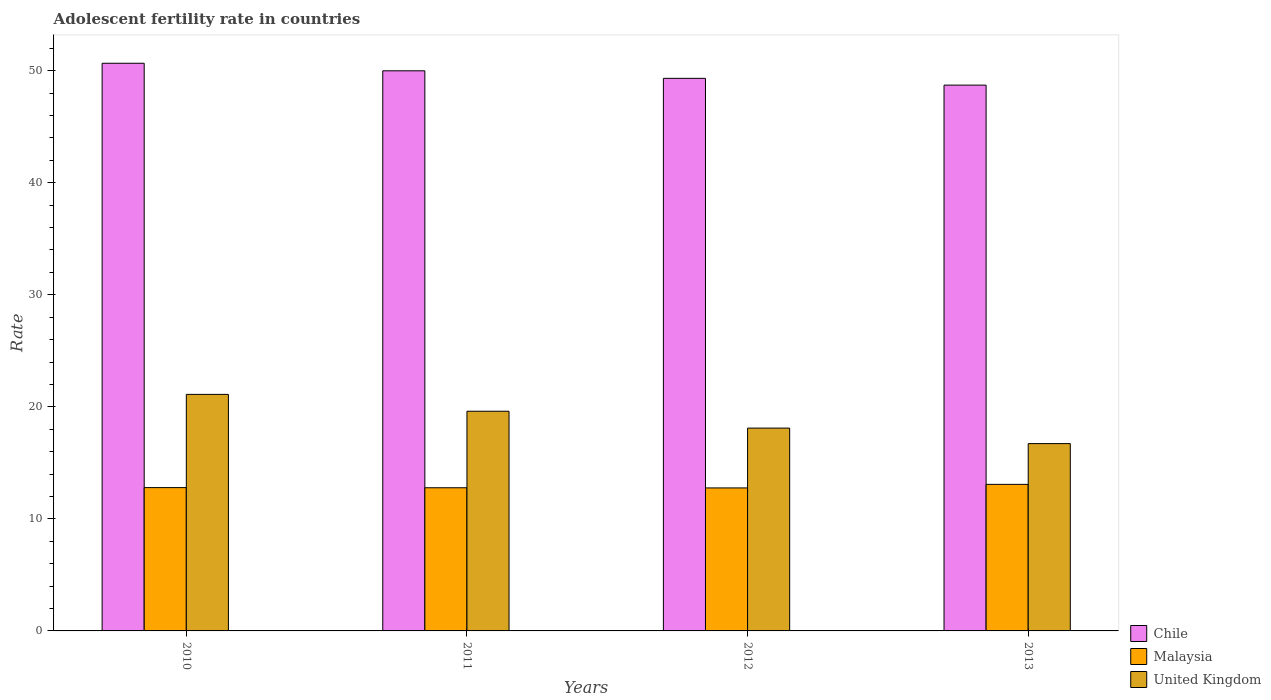How many different coloured bars are there?
Offer a terse response. 3. Are the number of bars per tick equal to the number of legend labels?
Provide a short and direct response. Yes. Are the number of bars on each tick of the X-axis equal?
Your answer should be compact. Yes. In how many cases, is the number of bars for a given year not equal to the number of legend labels?
Provide a short and direct response. 0. What is the adolescent fertility rate in United Kingdom in 2013?
Offer a terse response. 16.72. Across all years, what is the maximum adolescent fertility rate in Chile?
Your response must be concise. 50.67. Across all years, what is the minimum adolescent fertility rate in United Kingdom?
Offer a very short reply. 16.72. What is the total adolescent fertility rate in Chile in the graph?
Offer a very short reply. 198.69. What is the difference between the adolescent fertility rate in Malaysia in 2011 and that in 2012?
Provide a succinct answer. 0.02. What is the difference between the adolescent fertility rate in United Kingdom in 2011 and the adolescent fertility rate in Chile in 2012?
Provide a succinct answer. -29.71. What is the average adolescent fertility rate in Chile per year?
Your answer should be very brief. 49.67. In the year 2010, what is the difference between the adolescent fertility rate in Malaysia and adolescent fertility rate in Chile?
Offer a very short reply. -37.87. What is the ratio of the adolescent fertility rate in Malaysia in 2010 to that in 2012?
Provide a succinct answer. 1. Is the adolescent fertility rate in Chile in 2010 less than that in 2011?
Offer a very short reply. No. What is the difference between the highest and the second highest adolescent fertility rate in Malaysia?
Give a very brief answer. 0.29. What is the difference between the highest and the lowest adolescent fertility rate in Chile?
Give a very brief answer. 1.95. Is the sum of the adolescent fertility rate in Malaysia in 2010 and 2012 greater than the maximum adolescent fertility rate in Chile across all years?
Your answer should be very brief. No. What does the 2nd bar from the left in 2012 represents?
Give a very brief answer. Malaysia. What does the 2nd bar from the right in 2010 represents?
Your answer should be very brief. Malaysia. Is it the case that in every year, the sum of the adolescent fertility rate in Malaysia and adolescent fertility rate in Chile is greater than the adolescent fertility rate in United Kingdom?
Make the answer very short. Yes. Are all the bars in the graph horizontal?
Offer a terse response. No. How are the legend labels stacked?
Offer a terse response. Vertical. What is the title of the graph?
Your response must be concise. Adolescent fertility rate in countries. What is the label or title of the X-axis?
Your answer should be very brief. Years. What is the label or title of the Y-axis?
Offer a very short reply. Rate. What is the Rate in Chile in 2010?
Ensure brevity in your answer.  50.67. What is the Rate of Malaysia in 2010?
Keep it short and to the point. 12.79. What is the Rate in United Kingdom in 2010?
Make the answer very short. 21.11. What is the Rate of Chile in 2011?
Keep it short and to the point. 49.99. What is the Rate of Malaysia in 2011?
Keep it short and to the point. 12.78. What is the Rate in United Kingdom in 2011?
Ensure brevity in your answer.  19.61. What is the Rate in Chile in 2012?
Your answer should be compact. 49.32. What is the Rate in Malaysia in 2012?
Your answer should be compact. 12.76. What is the Rate of United Kingdom in 2012?
Your answer should be compact. 18.1. What is the Rate of Chile in 2013?
Your answer should be very brief. 48.71. What is the Rate of Malaysia in 2013?
Provide a short and direct response. 13.08. What is the Rate of United Kingdom in 2013?
Ensure brevity in your answer.  16.72. Across all years, what is the maximum Rate of Chile?
Your answer should be very brief. 50.67. Across all years, what is the maximum Rate in Malaysia?
Keep it short and to the point. 13.08. Across all years, what is the maximum Rate of United Kingdom?
Provide a succinct answer. 21.11. Across all years, what is the minimum Rate in Chile?
Your response must be concise. 48.71. Across all years, what is the minimum Rate of Malaysia?
Make the answer very short. 12.76. Across all years, what is the minimum Rate in United Kingdom?
Offer a terse response. 16.72. What is the total Rate of Chile in the graph?
Provide a succinct answer. 198.69. What is the total Rate in Malaysia in the graph?
Your response must be concise. 51.41. What is the total Rate of United Kingdom in the graph?
Your response must be concise. 75.54. What is the difference between the Rate of Chile in 2010 and that in 2011?
Ensure brevity in your answer.  0.67. What is the difference between the Rate of Malaysia in 2010 and that in 2011?
Keep it short and to the point. 0.02. What is the difference between the Rate in United Kingdom in 2010 and that in 2011?
Your answer should be very brief. 1.5. What is the difference between the Rate in Chile in 2010 and that in 2012?
Give a very brief answer. 1.35. What is the difference between the Rate in Malaysia in 2010 and that in 2012?
Your answer should be compact. 0.03. What is the difference between the Rate in United Kingdom in 2010 and that in 2012?
Your answer should be compact. 3.01. What is the difference between the Rate of Chile in 2010 and that in 2013?
Offer a very short reply. 1.95. What is the difference between the Rate of Malaysia in 2010 and that in 2013?
Keep it short and to the point. -0.29. What is the difference between the Rate of United Kingdom in 2010 and that in 2013?
Provide a short and direct response. 4.39. What is the difference between the Rate of Chile in 2011 and that in 2012?
Keep it short and to the point. 0.67. What is the difference between the Rate in Malaysia in 2011 and that in 2012?
Provide a short and direct response. 0.02. What is the difference between the Rate in United Kingdom in 2011 and that in 2012?
Your response must be concise. 1.5. What is the difference between the Rate of Chile in 2011 and that in 2013?
Your response must be concise. 1.28. What is the difference between the Rate of Malaysia in 2011 and that in 2013?
Offer a terse response. -0.3. What is the difference between the Rate in United Kingdom in 2011 and that in 2013?
Offer a very short reply. 2.89. What is the difference between the Rate in Chile in 2012 and that in 2013?
Provide a short and direct response. 0.61. What is the difference between the Rate in Malaysia in 2012 and that in 2013?
Give a very brief answer. -0.32. What is the difference between the Rate in United Kingdom in 2012 and that in 2013?
Make the answer very short. 1.38. What is the difference between the Rate of Chile in 2010 and the Rate of Malaysia in 2011?
Keep it short and to the point. 37.89. What is the difference between the Rate of Chile in 2010 and the Rate of United Kingdom in 2011?
Your answer should be very brief. 31.06. What is the difference between the Rate in Malaysia in 2010 and the Rate in United Kingdom in 2011?
Your answer should be compact. -6.82. What is the difference between the Rate in Chile in 2010 and the Rate in Malaysia in 2012?
Your answer should be compact. 37.9. What is the difference between the Rate of Chile in 2010 and the Rate of United Kingdom in 2012?
Your answer should be very brief. 32.56. What is the difference between the Rate of Malaysia in 2010 and the Rate of United Kingdom in 2012?
Offer a very short reply. -5.31. What is the difference between the Rate in Chile in 2010 and the Rate in Malaysia in 2013?
Give a very brief answer. 37.59. What is the difference between the Rate in Chile in 2010 and the Rate in United Kingdom in 2013?
Give a very brief answer. 33.95. What is the difference between the Rate in Malaysia in 2010 and the Rate in United Kingdom in 2013?
Make the answer very short. -3.93. What is the difference between the Rate of Chile in 2011 and the Rate of Malaysia in 2012?
Provide a short and direct response. 37.23. What is the difference between the Rate of Chile in 2011 and the Rate of United Kingdom in 2012?
Provide a succinct answer. 31.89. What is the difference between the Rate in Malaysia in 2011 and the Rate in United Kingdom in 2012?
Make the answer very short. -5.33. What is the difference between the Rate in Chile in 2011 and the Rate in Malaysia in 2013?
Provide a short and direct response. 36.91. What is the difference between the Rate in Chile in 2011 and the Rate in United Kingdom in 2013?
Your answer should be compact. 33.27. What is the difference between the Rate in Malaysia in 2011 and the Rate in United Kingdom in 2013?
Keep it short and to the point. -3.94. What is the difference between the Rate in Chile in 2012 and the Rate in Malaysia in 2013?
Your answer should be compact. 36.24. What is the difference between the Rate in Chile in 2012 and the Rate in United Kingdom in 2013?
Provide a short and direct response. 32.6. What is the difference between the Rate of Malaysia in 2012 and the Rate of United Kingdom in 2013?
Offer a very short reply. -3.96. What is the average Rate of Chile per year?
Your answer should be very brief. 49.67. What is the average Rate in Malaysia per year?
Provide a short and direct response. 12.85. What is the average Rate of United Kingdom per year?
Offer a terse response. 18.89. In the year 2010, what is the difference between the Rate of Chile and Rate of Malaysia?
Your answer should be compact. 37.87. In the year 2010, what is the difference between the Rate in Chile and Rate in United Kingdom?
Provide a succinct answer. 29.55. In the year 2010, what is the difference between the Rate in Malaysia and Rate in United Kingdom?
Your answer should be very brief. -8.32. In the year 2011, what is the difference between the Rate in Chile and Rate in Malaysia?
Provide a short and direct response. 37.22. In the year 2011, what is the difference between the Rate of Chile and Rate of United Kingdom?
Offer a very short reply. 30.39. In the year 2011, what is the difference between the Rate in Malaysia and Rate in United Kingdom?
Keep it short and to the point. -6.83. In the year 2012, what is the difference between the Rate in Chile and Rate in Malaysia?
Give a very brief answer. 36.56. In the year 2012, what is the difference between the Rate of Chile and Rate of United Kingdom?
Offer a very short reply. 31.22. In the year 2012, what is the difference between the Rate in Malaysia and Rate in United Kingdom?
Your response must be concise. -5.34. In the year 2013, what is the difference between the Rate in Chile and Rate in Malaysia?
Provide a short and direct response. 35.63. In the year 2013, what is the difference between the Rate in Chile and Rate in United Kingdom?
Offer a very short reply. 32. In the year 2013, what is the difference between the Rate of Malaysia and Rate of United Kingdom?
Provide a succinct answer. -3.64. What is the ratio of the Rate of Chile in 2010 to that in 2011?
Provide a short and direct response. 1.01. What is the ratio of the Rate of United Kingdom in 2010 to that in 2011?
Offer a terse response. 1.08. What is the ratio of the Rate of Chile in 2010 to that in 2012?
Make the answer very short. 1.03. What is the ratio of the Rate in United Kingdom in 2010 to that in 2012?
Ensure brevity in your answer.  1.17. What is the ratio of the Rate of Chile in 2010 to that in 2013?
Keep it short and to the point. 1.04. What is the ratio of the Rate of United Kingdom in 2010 to that in 2013?
Provide a succinct answer. 1.26. What is the ratio of the Rate of Chile in 2011 to that in 2012?
Provide a short and direct response. 1.01. What is the ratio of the Rate of United Kingdom in 2011 to that in 2012?
Keep it short and to the point. 1.08. What is the ratio of the Rate of Chile in 2011 to that in 2013?
Provide a short and direct response. 1.03. What is the ratio of the Rate of Malaysia in 2011 to that in 2013?
Offer a very short reply. 0.98. What is the ratio of the Rate of United Kingdom in 2011 to that in 2013?
Provide a short and direct response. 1.17. What is the ratio of the Rate of Chile in 2012 to that in 2013?
Provide a short and direct response. 1.01. What is the ratio of the Rate of Malaysia in 2012 to that in 2013?
Make the answer very short. 0.98. What is the ratio of the Rate of United Kingdom in 2012 to that in 2013?
Provide a short and direct response. 1.08. What is the difference between the highest and the second highest Rate in Chile?
Offer a terse response. 0.67. What is the difference between the highest and the second highest Rate in Malaysia?
Your answer should be very brief. 0.29. What is the difference between the highest and the second highest Rate of United Kingdom?
Provide a short and direct response. 1.5. What is the difference between the highest and the lowest Rate in Chile?
Ensure brevity in your answer.  1.95. What is the difference between the highest and the lowest Rate of Malaysia?
Ensure brevity in your answer.  0.32. What is the difference between the highest and the lowest Rate of United Kingdom?
Offer a very short reply. 4.39. 